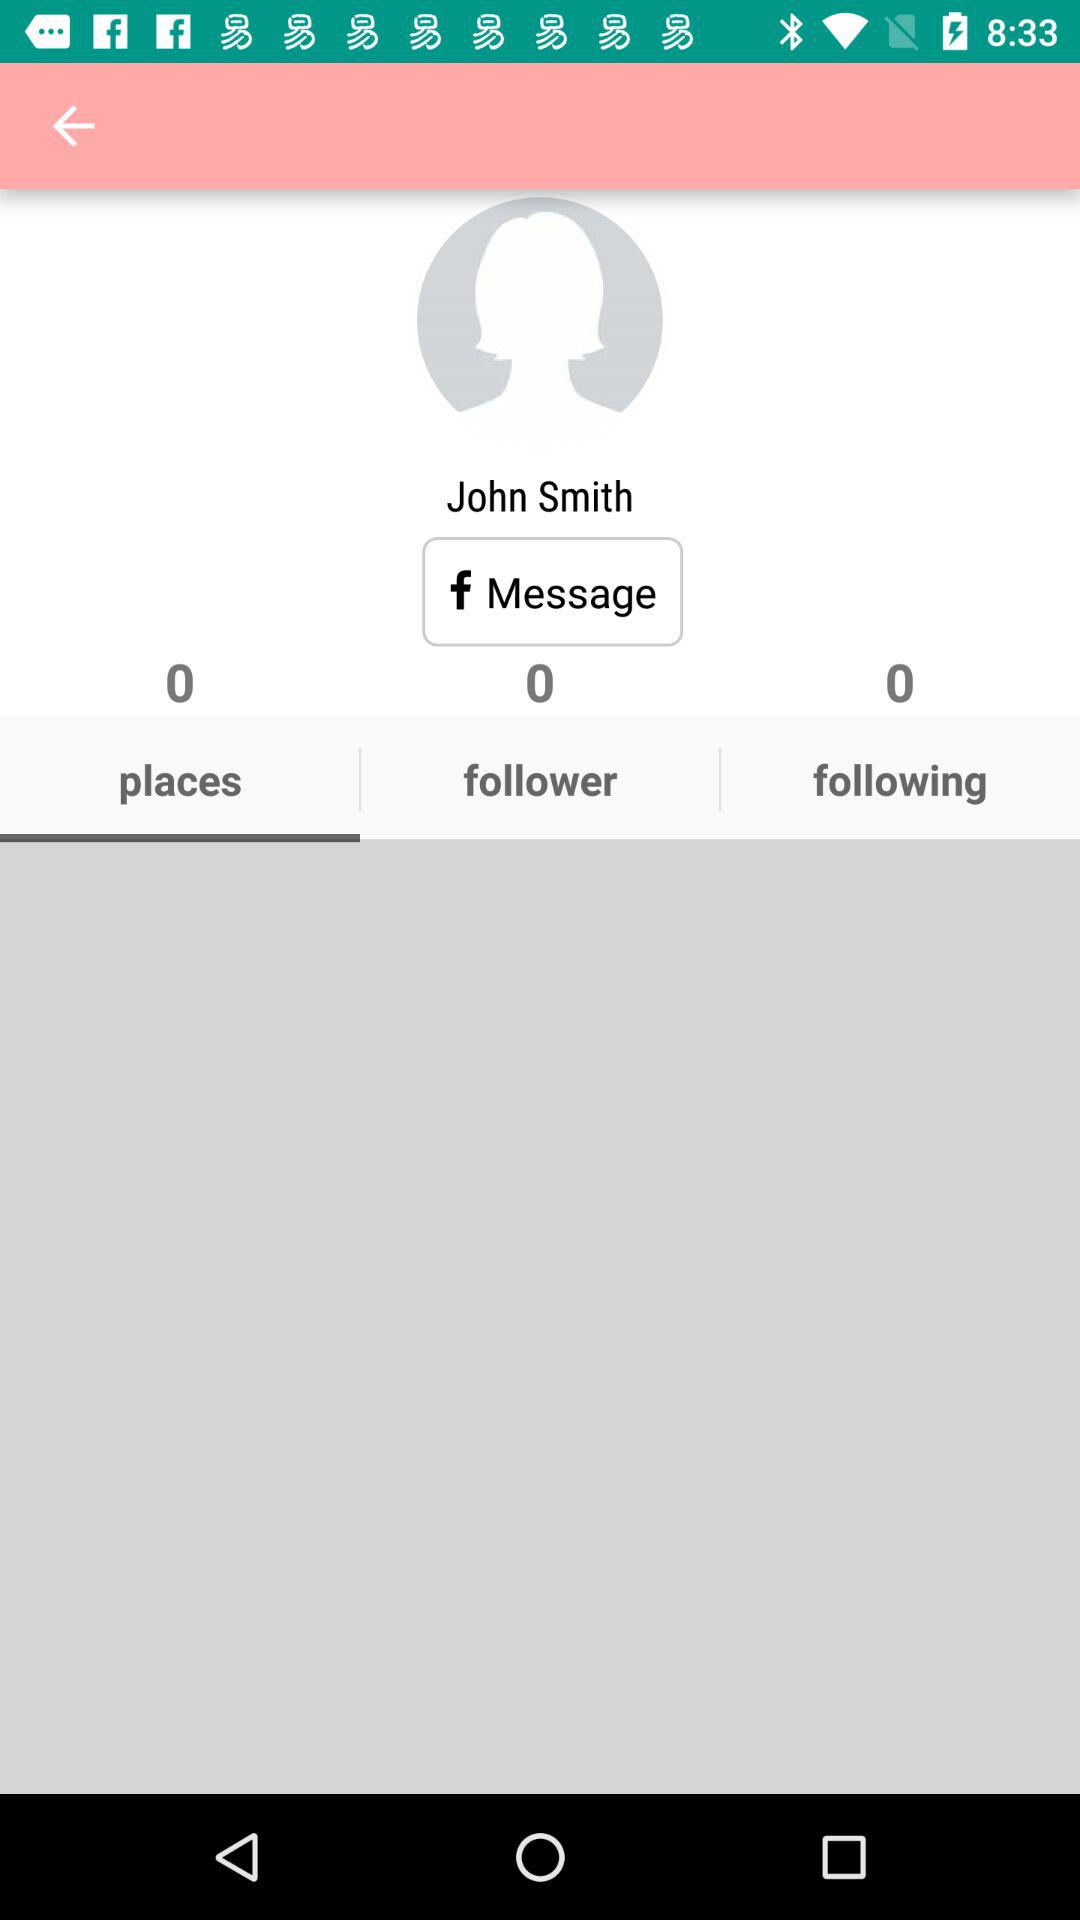What is the name of the user? The username is "John Smith". 